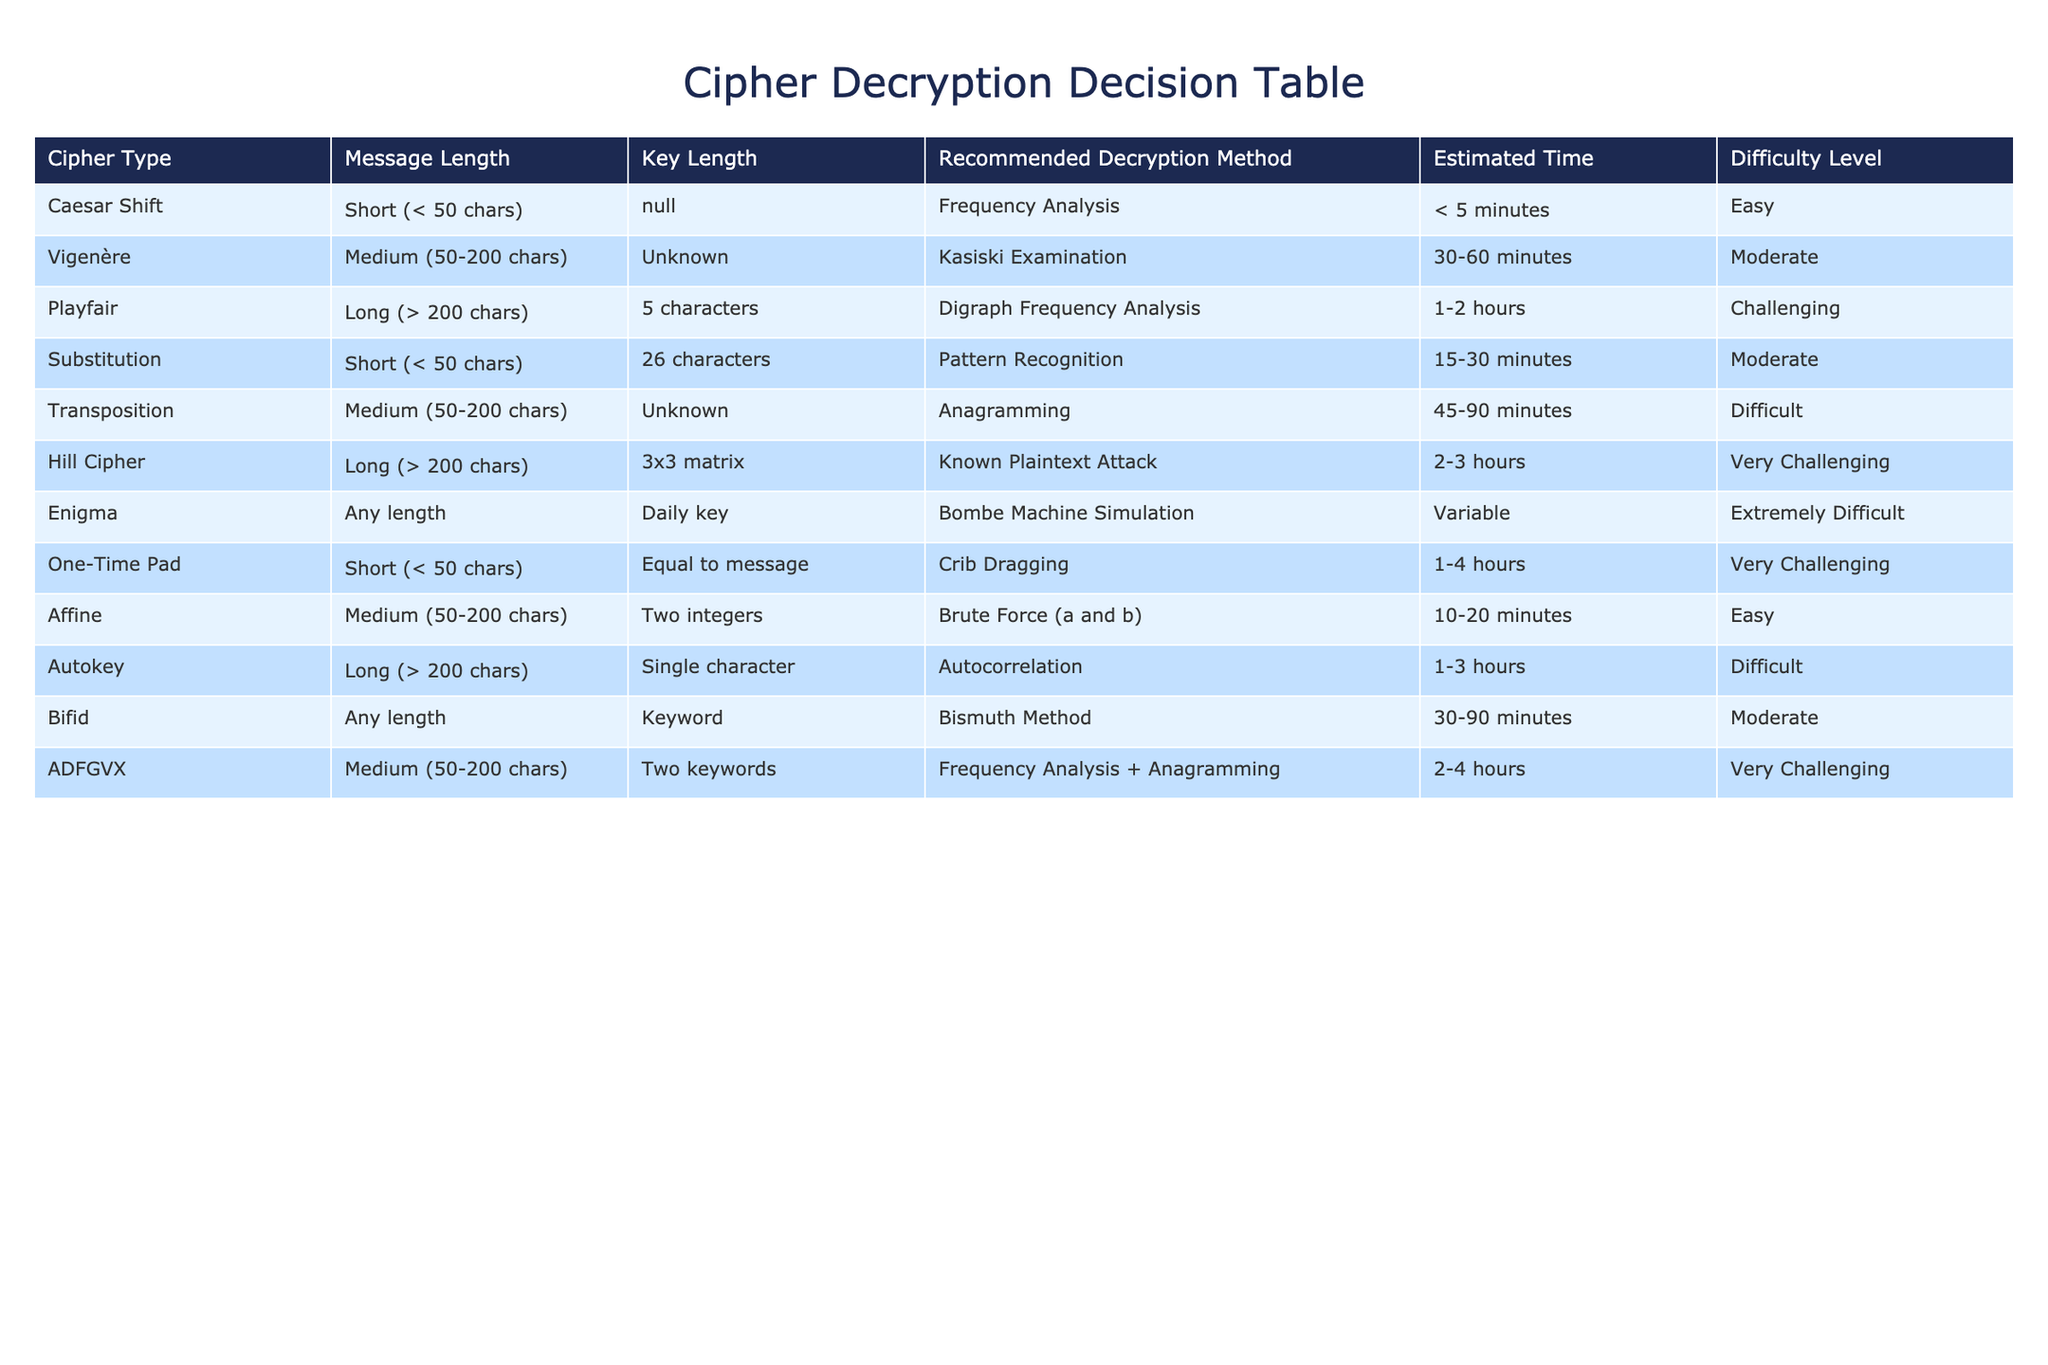What is the recommended decryption method for a short Caesar cipher message? The table shows that for a short message encrypted with a Caesar shift, the recommended decryption method is frequency analysis. This is directly listed under the 'Recommended Decryption Method' column for the 'Caesar Shift' cipher type.
Answer: Frequency Analysis What is the estimated time for decrypting a medium-length Vigenère cipher? According to the table, the estimated time for decrypting a medium-length Vigenère message is between 30 and 60 minutes. This information is found in the 'Estimated Time' column corresponding to the 'Vigenère' cipher type.
Answer: 30-60 minutes True or False: The Playfair cipher is estimated to take less time to decrypt than the ADFGVX cipher. By checking the estimated times for both ciphers in the table, we can see that Playfair takes 1-2 hours to decrypt while ADFGVX takes 2-4 hours. Since 1-2 hours is less than 2-4 hours, the statement is true.
Answer: True If a message is long and encrypted with the Hill cipher, which decryption method should be used? The table indicates that for long messages encrypted with a Hill cipher, the recommended decryption method is a known plaintext attack. This is found under the 'Recommended Decryption Method' column for the 'Hill Cipher' type.
Answer: Known Plaintext Attack What is the average time required for decrypting medium-length ciphers listed in the table? The table indicates that the estimated times for the medium-length ciphers (Vigenère, Transposition, Affine, ADFGVX) are 30-60 minutes, 45-90 minutes, 10-20 minutes, and 2-4 hours, respectively. To find the average, we first convert these ranges to minutes: (30 + 60) / 2 = 45, (45 + 90) / 2 = 67.5, (10 + 20) / 2 = 15, and (120 + 240) / 2 = 180. We then average the midpoint values (45 + 67.5 + 15 + 180) / 4 = 78.125 minutes.
Answer: 78.125 minutes What decryption method is suggested for both medium and long messages? From the table, we notice that the decryption methods for medium-length messages (Vigenère: Kasiski examination, Transposition: Anagramming, Affine: Brute force, ADFGVX: Frequency analysis + Anagramming) and long messages (Playfair: Digraph frequency analysis, Hill cipher: Known plaintext attack, Autokey: Autocorrelation) vary. The methods differ between the two categories, hence there is no single method suggested for both medium and long messages.
Answer: No common method 